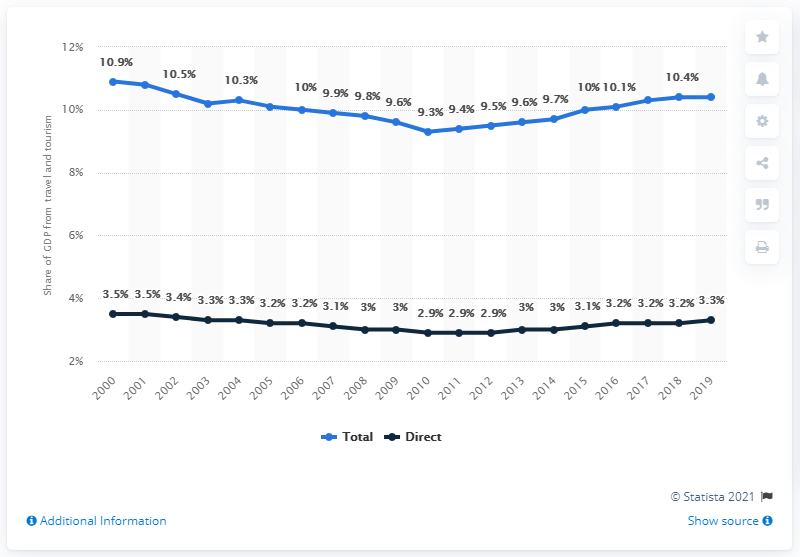List a handful of essential elements in this visual. In 2019, the travel and tourism industry contributed 10.4% of the global GDP. In 2019, the global travel and tourism industry accounted for 3.3% of the world's total Gross Domestic Product (GDP). 